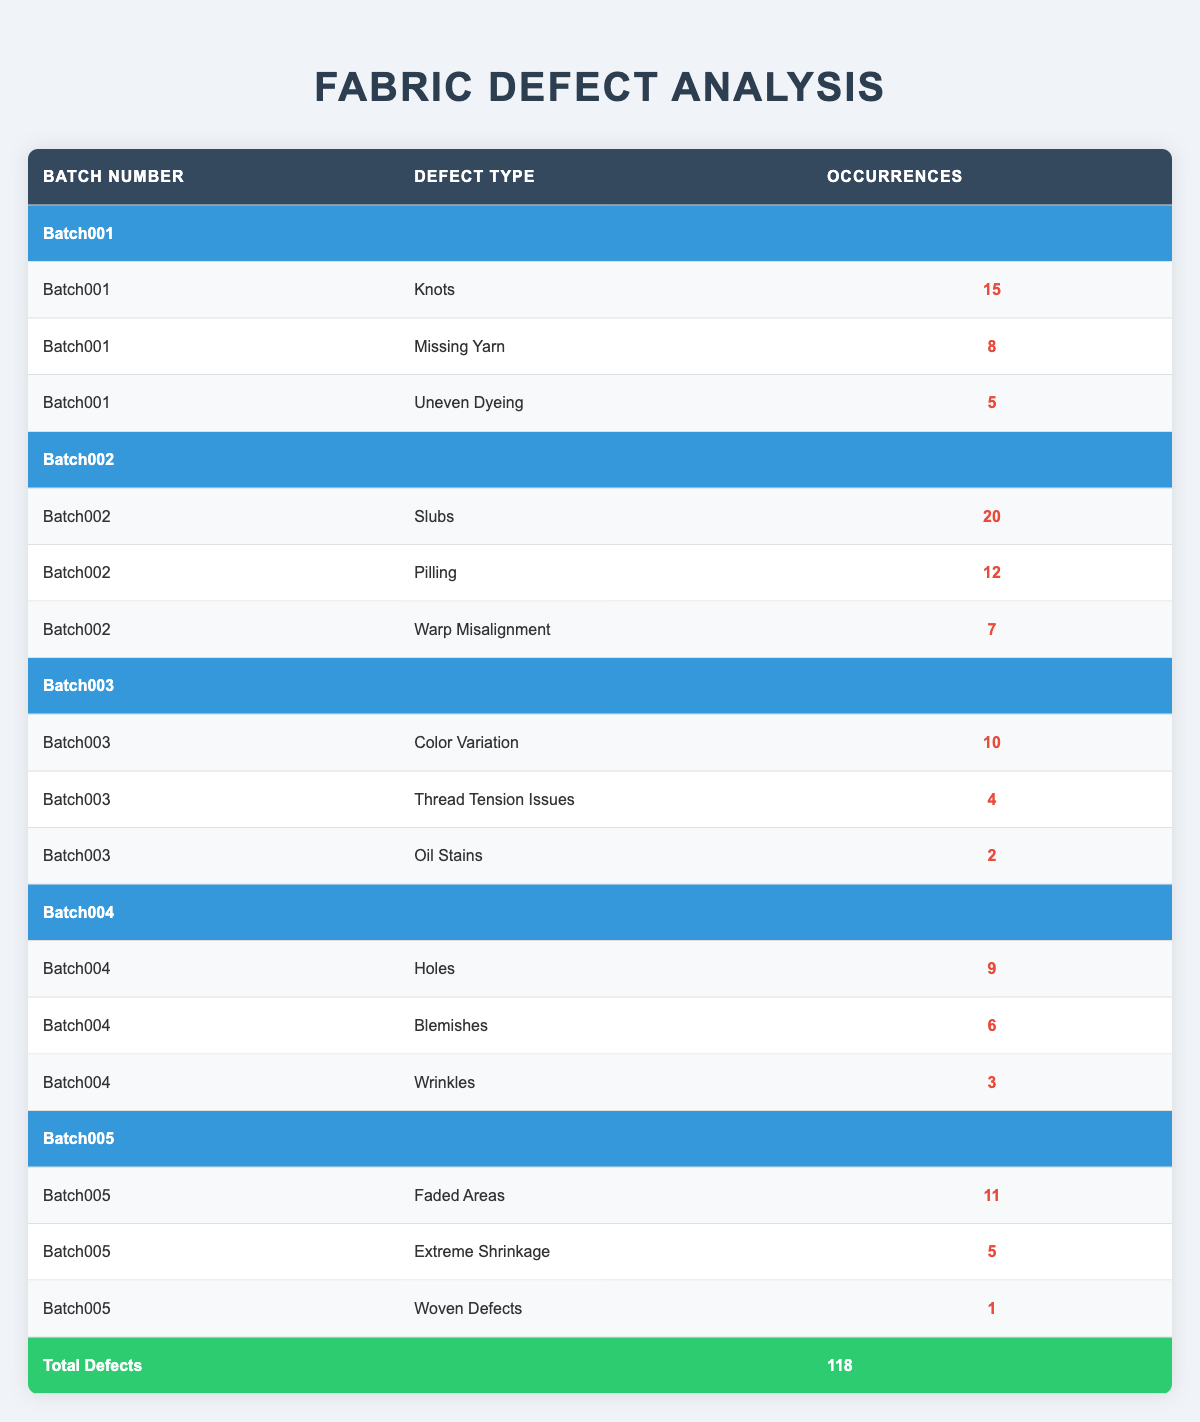What are the occurrences of "Knots" in Batch001? In Batch001, the defect type "Knots" has 15 occurrences listed in the table.
Answer: 15 Which batch has the highest number of total defects? To find the batch with the highest number of total defects, we need to sum the occurrences for each batch: Batch001 (15+8+5=28), Batch002 (20+12+7=39), Batch003 (10+4+2=16), Batch004 (9+6+3=18), Batch005 (11+5+1=17). Batch002 has the highest total with 39 occurrences.
Answer: Batch002 Is there any batch with a defect type called "Oil Stains"? The table includes Batch003 listed with "Oil Stains" having 2 occurrences. Therefore, the answer is yes.
Answer: Yes How many occurrences of "Faded Areas" are there? The table shows that "Faded Areas" under Batch005 has 11 occurrences.
Answer: 11 What is the difference in occurrences between the batch with the most "Pilling" and the one with the least "Wrinkles"? For Batch002, "Pilling" has 12 occurrences, and for Batch004, "Wrinkles" has 3 occurrences. The difference is 12 - 3 = 9.
Answer: 9 Does Batch004 have fewer total occurrences than Batch001? Total occurrences for Batch001 is 28, while Batch004 totals 18 (9+6+3=18). Since 18 is less than 28, the answer is yes.
Answer: Yes What is the average number of occurrences for all defect types in Batch005? Batch005 has occurrences of 11, 5, and 1. Adding them gives us 17. To find the average, divide by the number of defect types, which is 3. Therefore, the average occurrences is 17/3 ≈ 5.67.
Answer: Approximately 5.67 Which defect type across all batches has the least occurrences? Looking at all the occurrences, the defect type with the least number is "Woven Defects" in Batch005 with 1 occurrence.
Answer: Woven Defects How many total occurrences are there across all batches? We sum all the occurrences from the table: 15+8+5+20+12+7+10+4+2+9+6+3+11+5+1 = 118. Therefore, the total occurrences are 118.
Answer: 118 